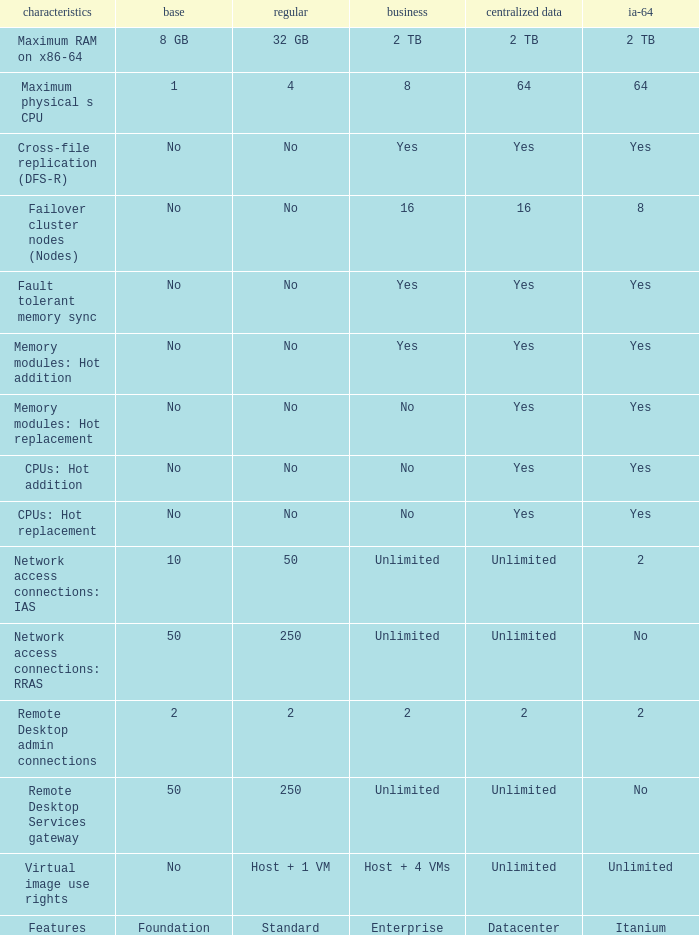What is the Enterprise for teh memory modules: hot replacement Feature that has a Datacenter of Yes? No. 